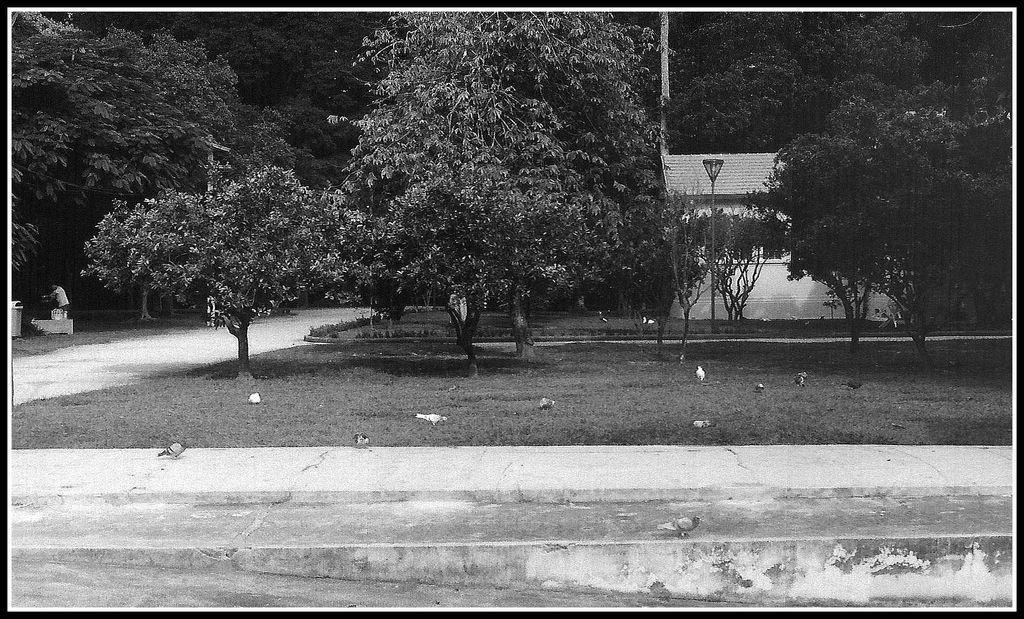How would you summarize this image in a sentence or two? It is an edited image,in the garden is plenty of trees and behind the trees there is a house and behind the house there is a thicket. 